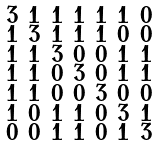<formula> <loc_0><loc_0><loc_500><loc_500>\begin{smallmatrix} 3 & 1 & 1 & 1 & 1 & 1 & 0 \\ 1 & 3 & 1 & 1 & 1 & 0 & 0 \\ 1 & 1 & 3 & 0 & 0 & 1 & 1 \\ 1 & 1 & 0 & 3 & 0 & 1 & 1 \\ 1 & 1 & 0 & 0 & 3 & 0 & 0 \\ 1 & 0 & 1 & 1 & 0 & 3 & 1 \\ 0 & 0 & 1 & 1 & 0 & 1 & 3 \end{smallmatrix}</formula> 